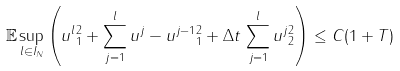<formula> <loc_0><loc_0><loc_500><loc_500>\mathbb { E } \sup _ { l \in I _ { N } } \left ( \| u ^ { l } \| _ { 1 } ^ { 2 } + \sum _ { j = 1 } ^ { l } \| u ^ { j } - u ^ { j - 1 } \| _ { 1 } ^ { 2 } + \Delta t \, \sum _ { j = 1 } ^ { l } \| u ^ { j } \| ^ { 2 } _ { 2 } \right ) \leq C ( 1 + T )</formula> 